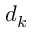<formula> <loc_0><loc_0><loc_500><loc_500>d _ { k }</formula> 